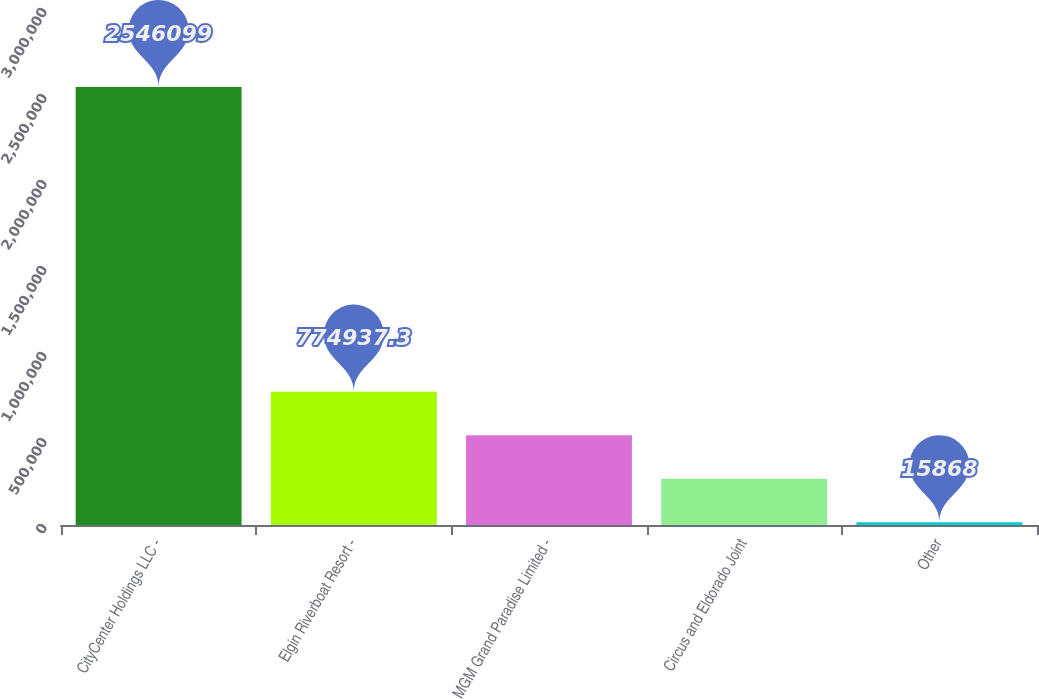<chart> <loc_0><loc_0><loc_500><loc_500><bar_chart><fcel>CityCenter Holdings LLC -<fcel>Elgin Riverboat Resort -<fcel>MGM Grand Paradise Limited -<fcel>Circus and Eldorado Joint<fcel>Other<nl><fcel>2.5461e+06<fcel>774937<fcel>521914<fcel>268891<fcel>15868<nl></chart> 